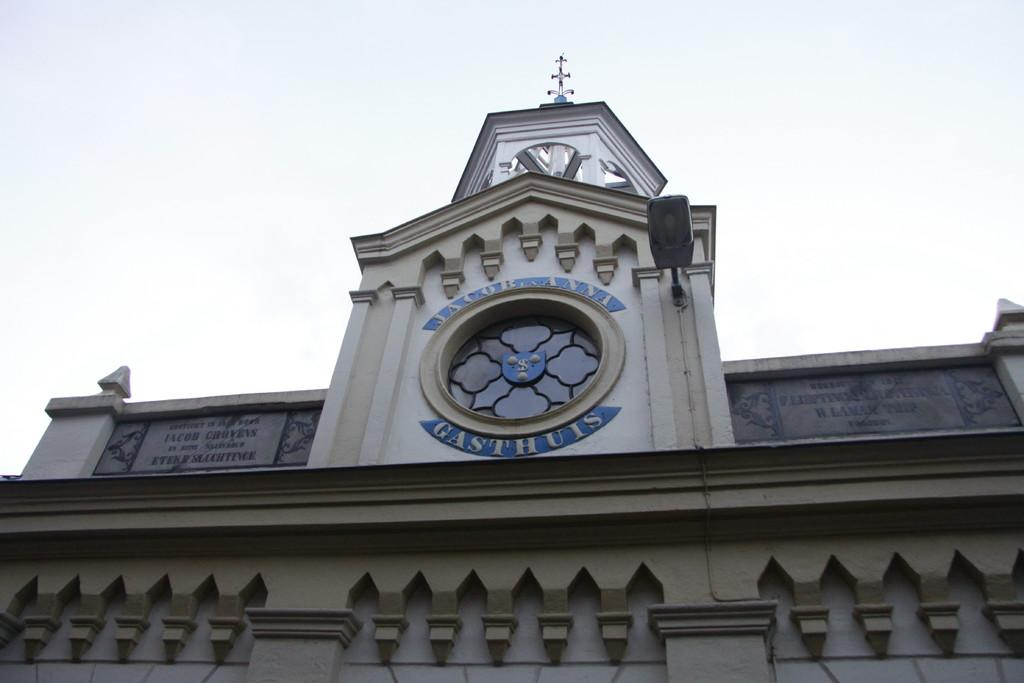What type of structure is present in the image? There is a building in the image. What can be seen in the background of the image? The sky is visible in the background of the image. Where is the expert's office located in the image? There is no expert or office mentioned or visible in the image. What type of lunch is being served in the image? There is no mention or indication of lunch in the image. 